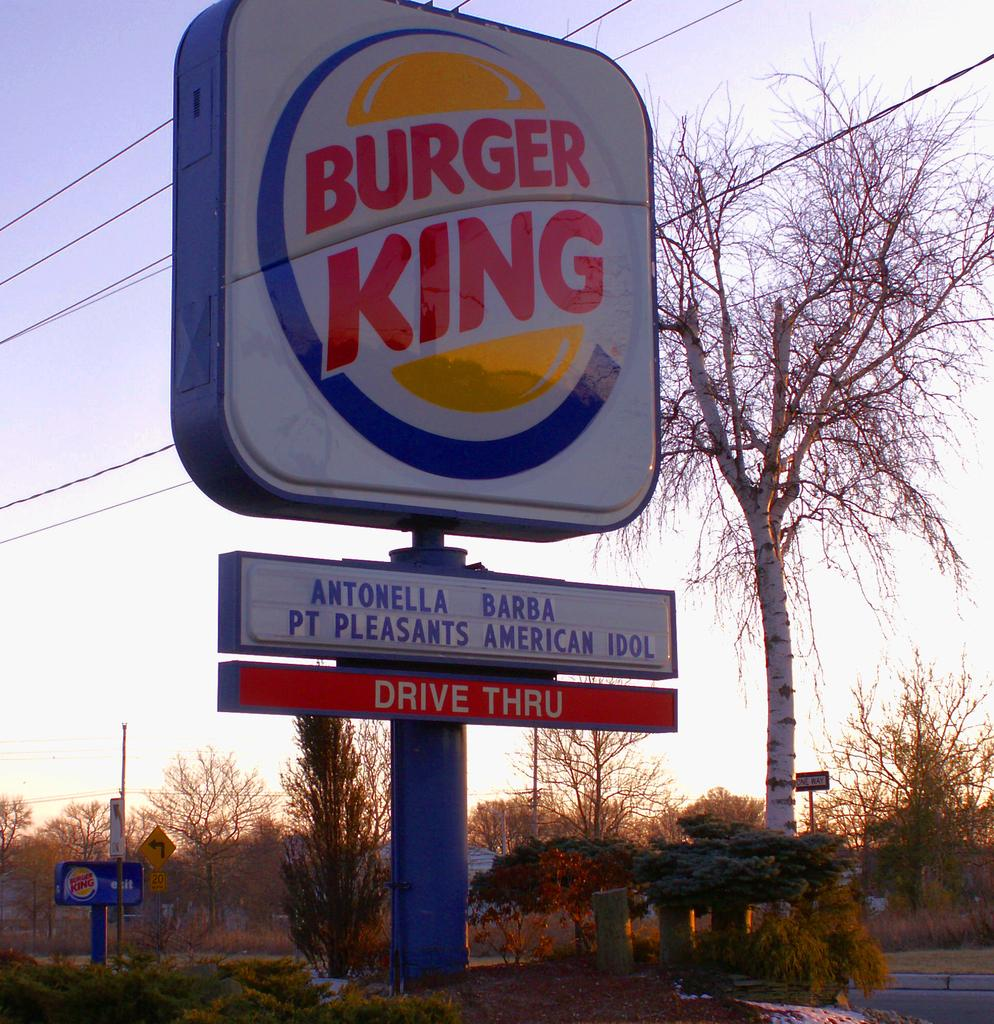<image>
Describe the image concisely. Burger King gives a shout out to Antonella Barba, Pt. Pleasant's American Idol. 